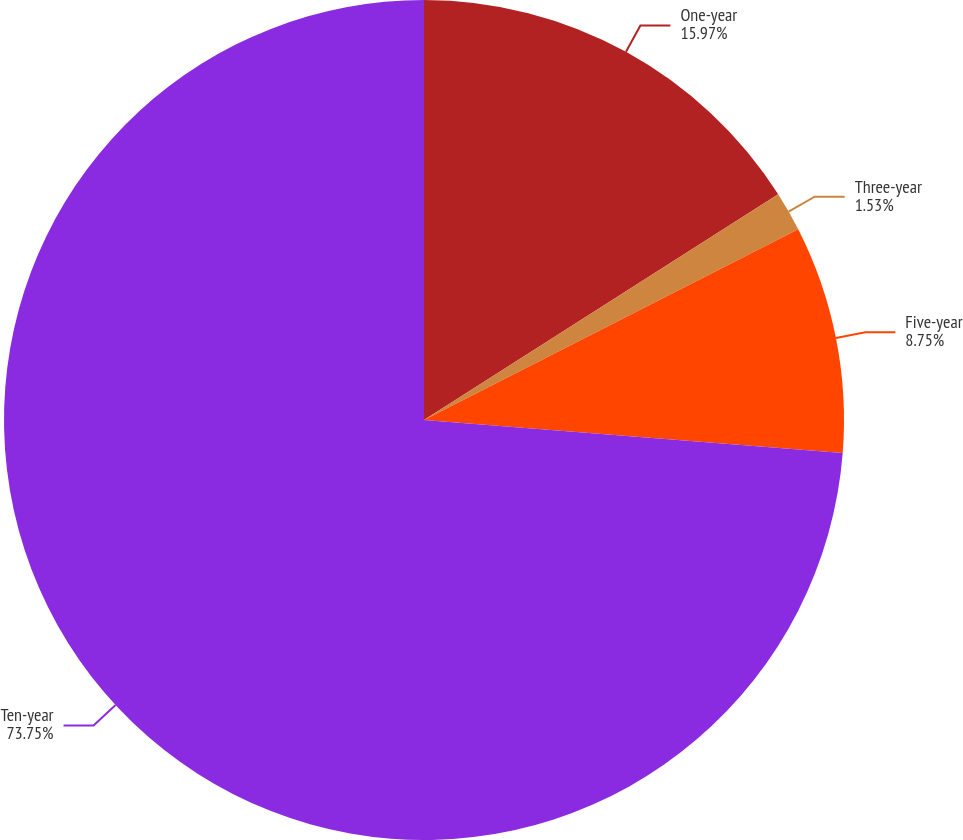Convert chart to OTSL. <chart><loc_0><loc_0><loc_500><loc_500><pie_chart><fcel>One-year<fcel>Three-year<fcel>Five-year<fcel>Ten-year<nl><fcel>15.97%<fcel>1.53%<fcel>8.75%<fcel>73.75%<nl></chart> 